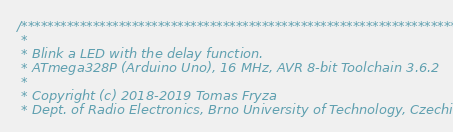Convert code to text. <code><loc_0><loc_0><loc_500><loc_500><_C_>/***********************************************************************
 * 
 * Blink a LED with the delay function.
 * ATmega328P (Arduino Uno), 16 MHz, AVR 8-bit Toolchain 3.6.2
 *
 * Copyright (c) 2018-2019 Tomas Fryza
 * Dept. of Radio Electronics, Brno University of Technology, Czechia</code> 